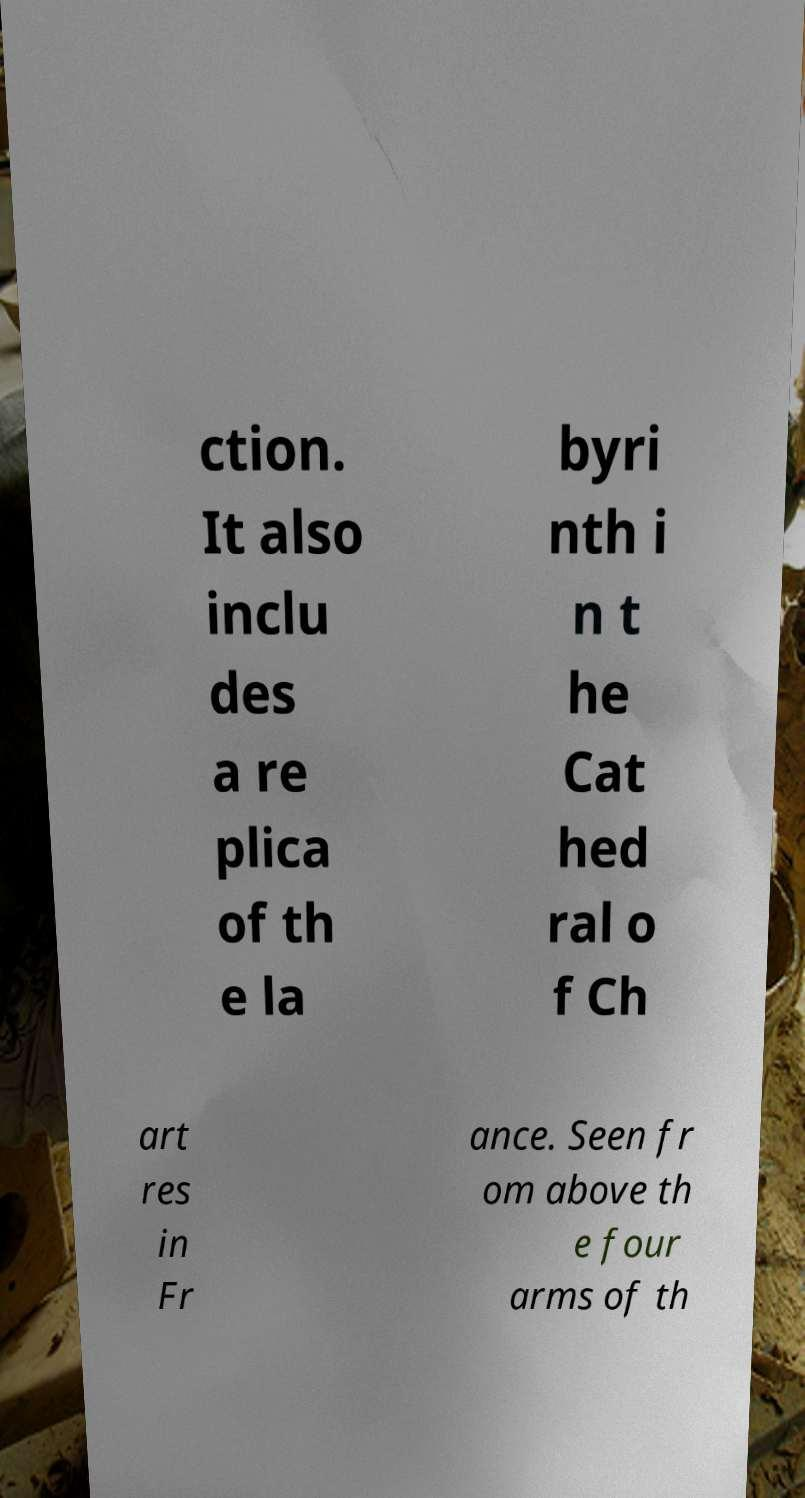Can you accurately transcribe the text from the provided image for me? ction. It also inclu des a re plica of th e la byri nth i n t he Cat hed ral o f Ch art res in Fr ance. Seen fr om above th e four arms of th 